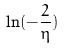Convert formula to latex. <formula><loc_0><loc_0><loc_500><loc_500>\ln ( - \frac { 2 } { \eta } )</formula> 